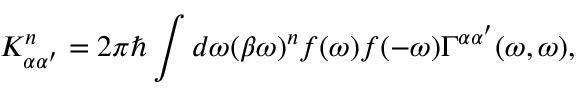<formula> <loc_0><loc_0><loc_500><loc_500>K _ { \alpha \alpha ^ { \prime } } ^ { n } = 2 \pi \hbar { \int } d \omega ( \beta \omega ) ^ { n } f ( \omega ) f ( - \omega ) \Gamma ^ { \alpha \alpha ^ { \prime } } ( \omega , \omega ) ,</formula> 